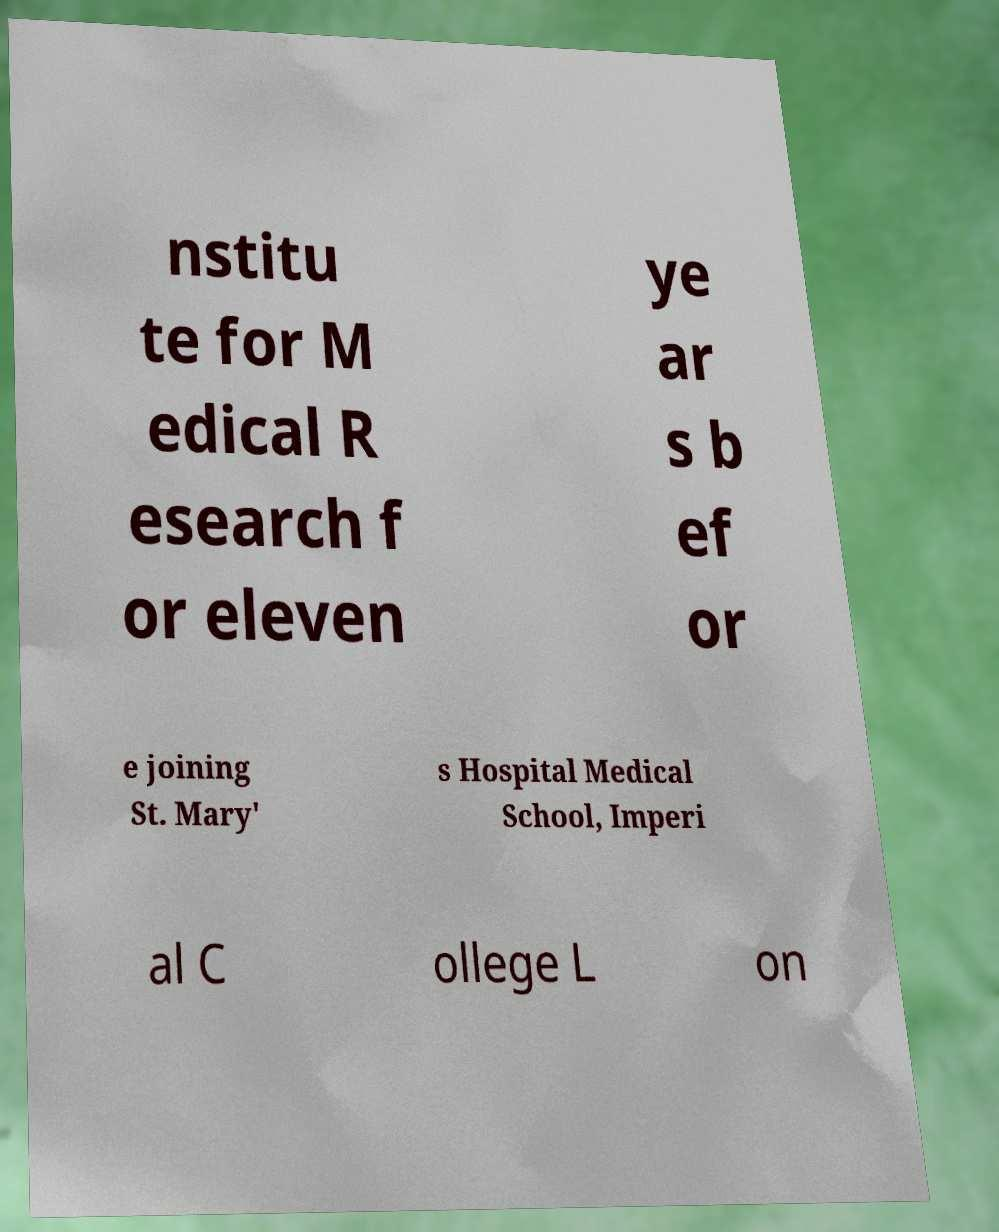I need the written content from this picture converted into text. Can you do that? nstitu te for M edical R esearch f or eleven ye ar s b ef or e joining St. Mary' s Hospital Medical School, Imperi al C ollege L on 